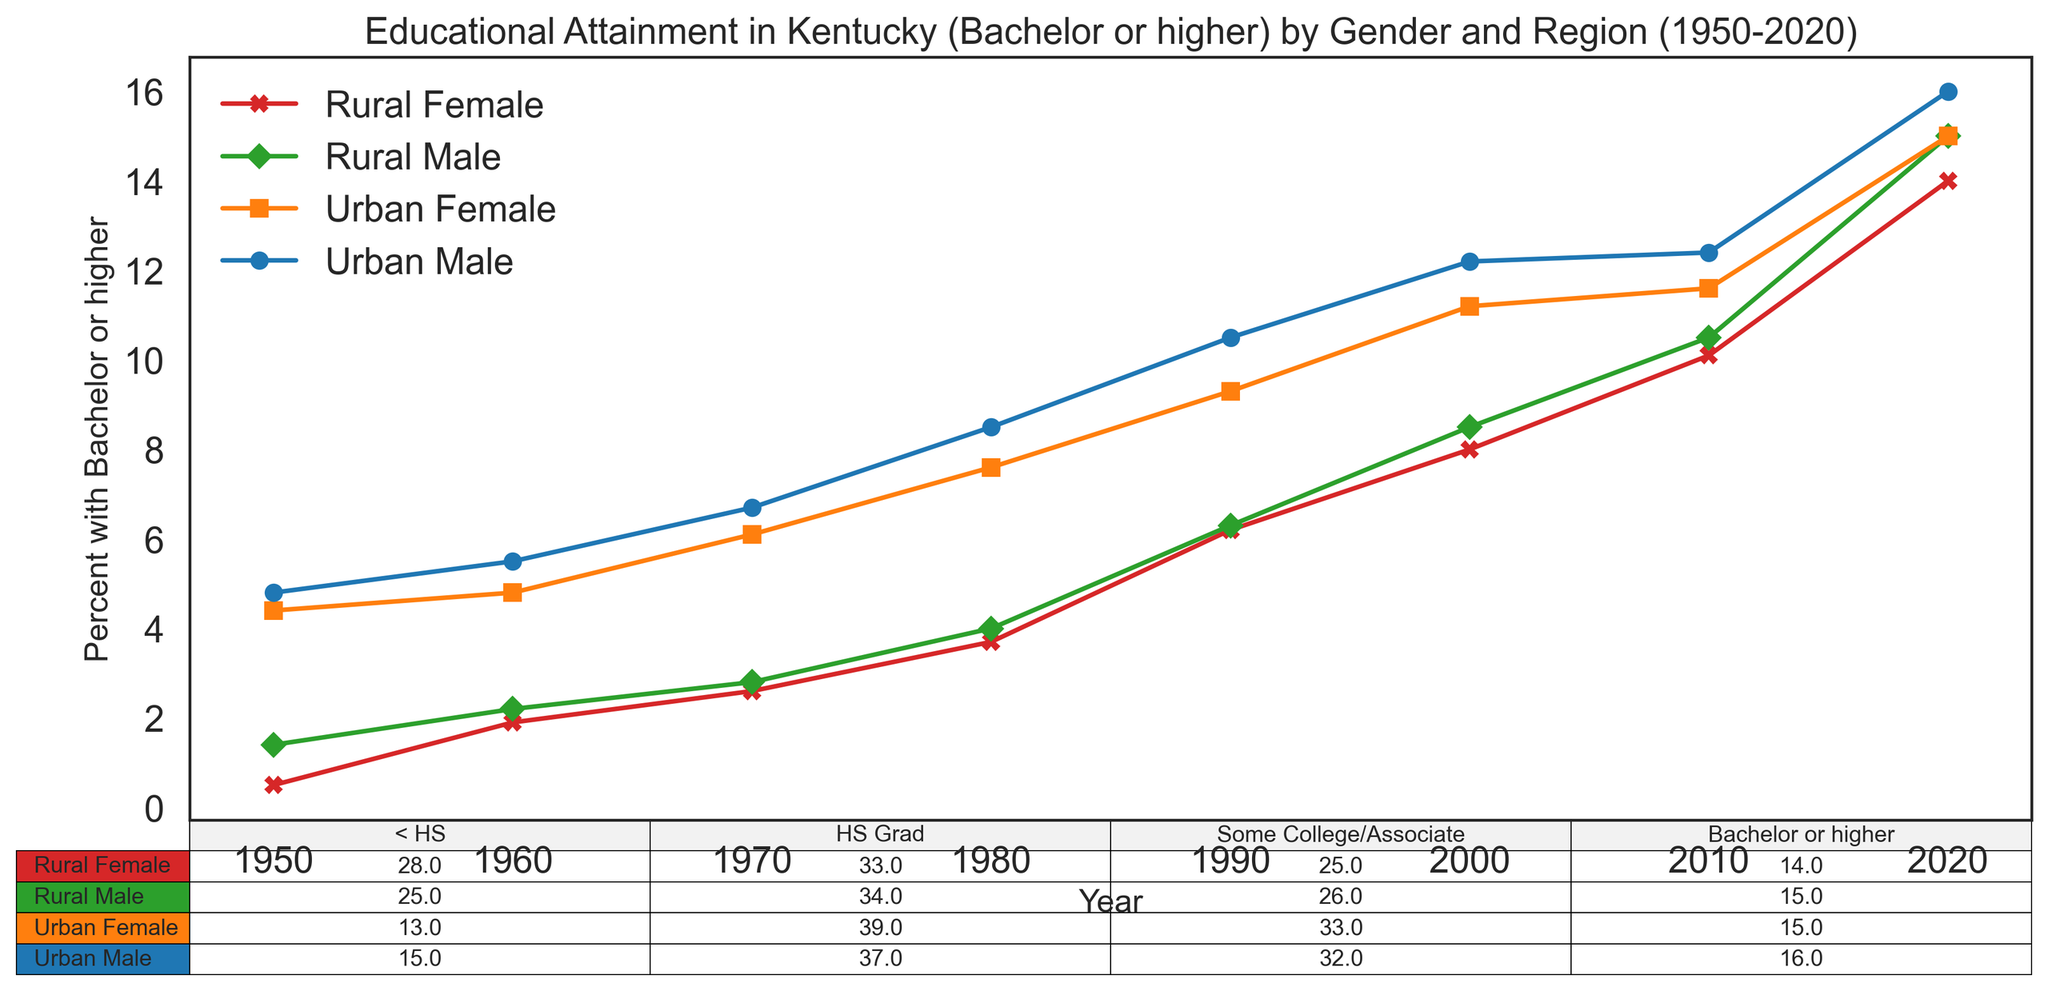What is the trend in the percentage of people with a Bachelor's degree or higher in Urban Kentucky from 1950 to 2020? Look at the line labeled 'Urban Male' and 'Urban Female'. Both lines show a consistent upward trend from 1950 to 2020, indicating that the percentage of people with a Bachelor's degree or higher in Urban Kentucky has increased over time.
Answer: Upward trend Which group had the highest percentage of people with a Bachelor's degree or higher in 2020? Look at the endpoints of the lines on the graph for the year 2020. The 'Urban Male' group has the highest percentage of people with a Bachelor’s degree or higher.
Answer: Urban Male Comparing Rural males and females in 2010, which group had a higher percentage of high school graduates? Refer to the data table and find the percentages for 'High_school' in 2010 for Rural males and females. Rural males had 35.6% and Rural females had 34.4%.
Answer: Rural males Which region and gender had the largest percentage increase in people with a Bachelor's degree or higher from 1950 to 2020? Subtract the 1950 percentages from the 2020 percentages for all groups, and compare their increments. The Urban Female group had the highest increase from 4.4% in 1950 to 15.0% in 2020, which is an increase of 10.6 percentage points.
Answer: Urban Female In which year did Urban females surpass Rural males in terms of the percentage of people with a Bachelor's degree or higher? Look at the intersection of the lines for 'Urban Female' and 'Rural Male'. Urban females surpassed Rural males around 1990.
Answer: 1990 What is the combined percentage of Urban males and females with some college or an associate degree in 2020? Add the percentages from the data table for 'Some_college_or_associate' in 2020 for Urban males (32.0%) and Urban females (33.0%). 32.0% + 33.0% = 65.0%.
Answer: 65.0% Which gender in Rural Kentucky had a lower percentage of people with less than a high school education in 1950? Refer to the data table for 1950. Rural males had 70.7% and Rural females had 72.5%, so Rural males had a lower percentage.
Answer: Rural males 